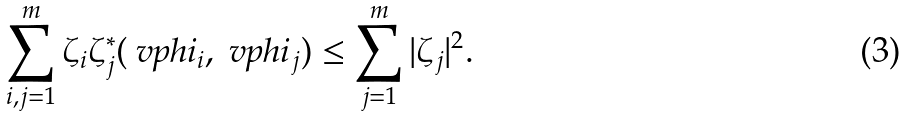Convert formula to latex. <formula><loc_0><loc_0><loc_500><loc_500>\sum _ { i , j = 1 } ^ { m } \zeta _ { i } \zeta _ { j } ^ { * } ( \ v p h i _ { i } , \ v p h i _ { j } ) \leq \sum _ { j = 1 } ^ { m } | \zeta _ { j } | ^ { 2 } .</formula> 